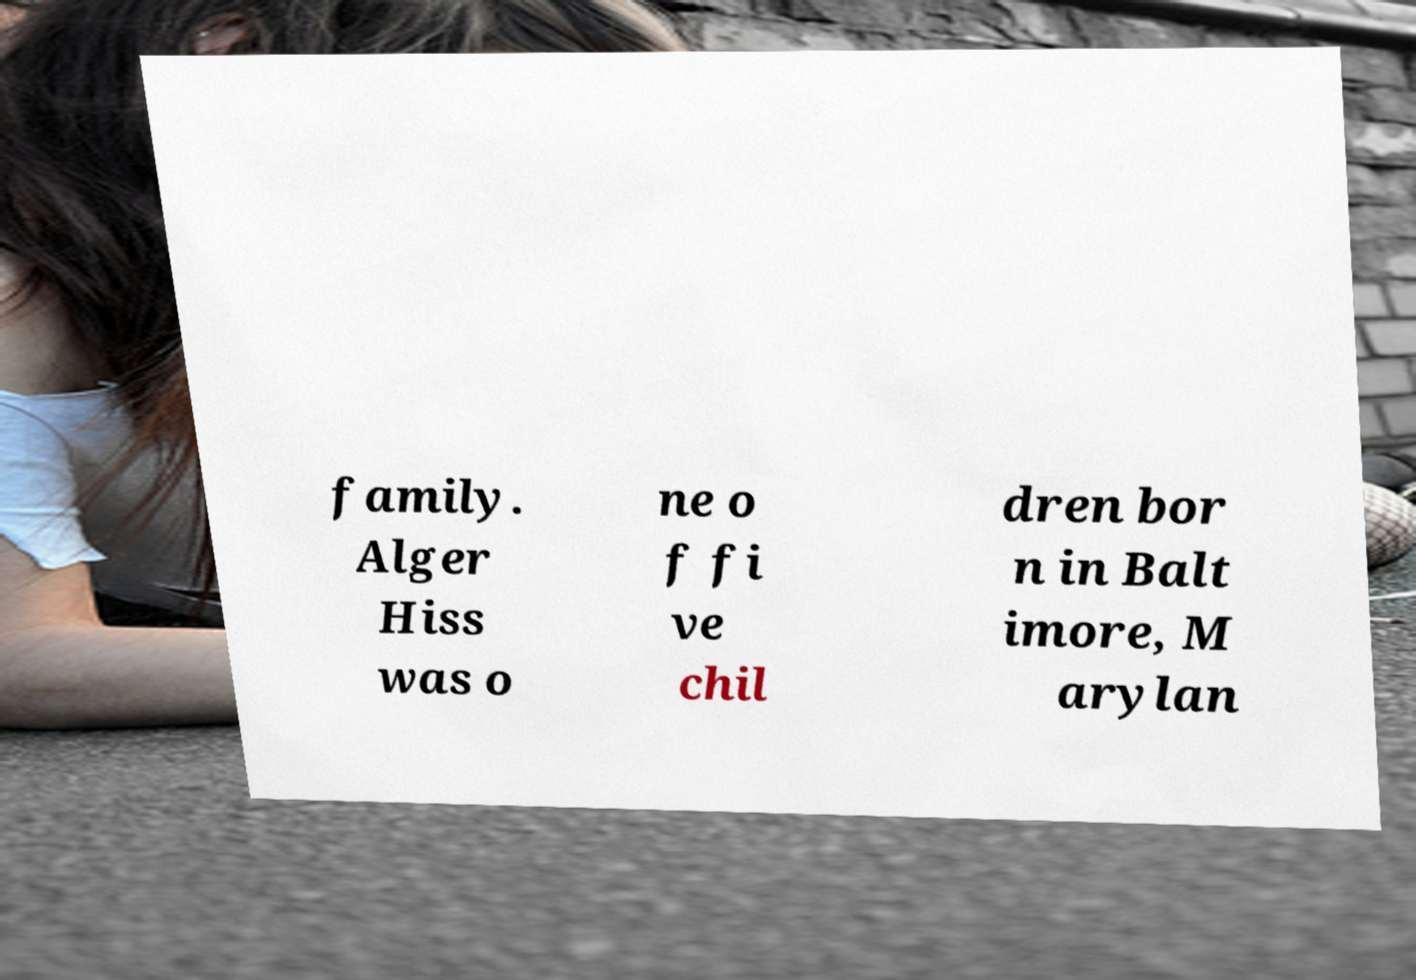I need the written content from this picture converted into text. Can you do that? family. Alger Hiss was o ne o f fi ve chil dren bor n in Balt imore, M arylan 